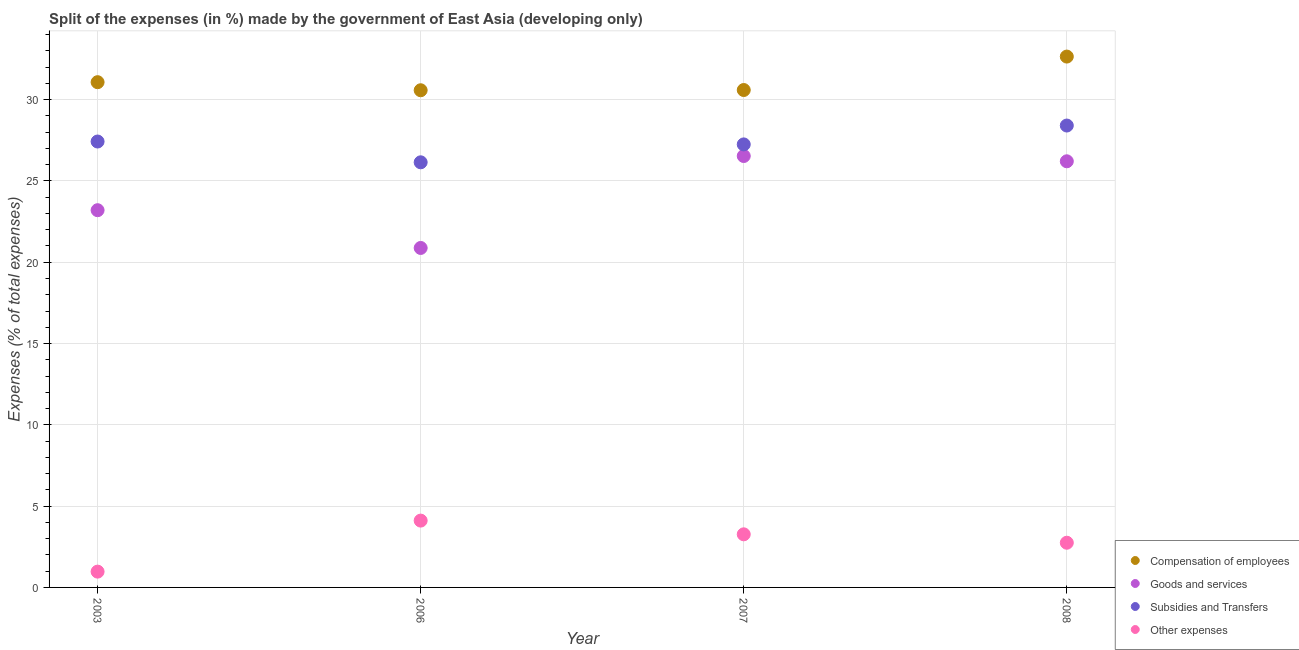What is the percentage of amount spent on other expenses in 2003?
Offer a terse response. 0.97. Across all years, what is the maximum percentage of amount spent on other expenses?
Your response must be concise. 4.11. Across all years, what is the minimum percentage of amount spent on subsidies?
Your answer should be very brief. 26.15. In which year was the percentage of amount spent on compensation of employees minimum?
Provide a short and direct response. 2006. What is the total percentage of amount spent on goods and services in the graph?
Provide a succinct answer. 96.82. What is the difference between the percentage of amount spent on goods and services in 2003 and that in 2008?
Your answer should be compact. -3.01. What is the difference between the percentage of amount spent on subsidies in 2006 and the percentage of amount spent on compensation of employees in 2008?
Your answer should be compact. -6.5. What is the average percentage of amount spent on other expenses per year?
Your answer should be very brief. 2.77. In the year 2003, what is the difference between the percentage of amount spent on goods and services and percentage of amount spent on subsidies?
Provide a succinct answer. -4.22. In how many years, is the percentage of amount spent on subsidies greater than 25 %?
Make the answer very short. 4. What is the ratio of the percentage of amount spent on subsidies in 2006 to that in 2007?
Give a very brief answer. 0.96. What is the difference between the highest and the second highest percentage of amount spent on other expenses?
Your answer should be compact. 0.84. What is the difference between the highest and the lowest percentage of amount spent on subsidies?
Provide a short and direct response. 2.26. In how many years, is the percentage of amount spent on goods and services greater than the average percentage of amount spent on goods and services taken over all years?
Your answer should be compact. 2. Is it the case that in every year, the sum of the percentage of amount spent on compensation of employees and percentage of amount spent on goods and services is greater than the percentage of amount spent on subsidies?
Your answer should be compact. Yes. Does the percentage of amount spent on other expenses monotonically increase over the years?
Give a very brief answer. No. Is the percentage of amount spent on other expenses strictly less than the percentage of amount spent on subsidies over the years?
Offer a very short reply. Yes. How many dotlines are there?
Your answer should be very brief. 4. How many years are there in the graph?
Provide a short and direct response. 4. Are the values on the major ticks of Y-axis written in scientific E-notation?
Keep it short and to the point. No. Does the graph contain any zero values?
Keep it short and to the point. No. Does the graph contain grids?
Make the answer very short. Yes. Where does the legend appear in the graph?
Give a very brief answer. Bottom right. How are the legend labels stacked?
Make the answer very short. Vertical. What is the title of the graph?
Your response must be concise. Split of the expenses (in %) made by the government of East Asia (developing only). What is the label or title of the Y-axis?
Your answer should be very brief. Expenses (% of total expenses). What is the Expenses (% of total expenses) of Compensation of employees in 2003?
Your answer should be very brief. 31.07. What is the Expenses (% of total expenses) in Goods and services in 2003?
Keep it short and to the point. 23.2. What is the Expenses (% of total expenses) in Subsidies and Transfers in 2003?
Your response must be concise. 27.42. What is the Expenses (% of total expenses) in Other expenses in 2003?
Provide a succinct answer. 0.97. What is the Expenses (% of total expenses) of Compensation of employees in 2006?
Make the answer very short. 30.58. What is the Expenses (% of total expenses) in Goods and services in 2006?
Your response must be concise. 20.88. What is the Expenses (% of total expenses) of Subsidies and Transfers in 2006?
Ensure brevity in your answer.  26.15. What is the Expenses (% of total expenses) of Other expenses in 2006?
Make the answer very short. 4.11. What is the Expenses (% of total expenses) in Compensation of employees in 2007?
Your answer should be very brief. 30.59. What is the Expenses (% of total expenses) of Goods and services in 2007?
Your answer should be compact. 26.53. What is the Expenses (% of total expenses) of Subsidies and Transfers in 2007?
Provide a short and direct response. 27.25. What is the Expenses (% of total expenses) in Other expenses in 2007?
Offer a very short reply. 3.27. What is the Expenses (% of total expenses) of Compensation of employees in 2008?
Provide a succinct answer. 32.65. What is the Expenses (% of total expenses) of Goods and services in 2008?
Your answer should be compact. 26.21. What is the Expenses (% of total expenses) of Subsidies and Transfers in 2008?
Provide a succinct answer. 28.41. What is the Expenses (% of total expenses) in Other expenses in 2008?
Offer a very short reply. 2.75. Across all years, what is the maximum Expenses (% of total expenses) of Compensation of employees?
Offer a terse response. 32.65. Across all years, what is the maximum Expenses (% of total expenses) in Goods and services?
Ensure brevity in your answer.  26.53. Across all years, what is the maximum Expenses (% of total expenses) in Subsidies and Transfers?
Your answer should be very brief. 28.41. Across all years, what is the maximum Expenses (% of total expenses) of Other expenses?
Provide a succinct answer. 4.11. Across all years, what is the minimum Expenses (% of total expenses) of Compensation of employees?
Keep it short and to the point. 30.58. Across all years, what is the minimum Expenses (% of total expenses) in Goods and services?
Offer a very short reply. 20.88. Across all years, what is the minimum Expenses (% of total expenses) of Subsidies and Transfers?
Your answer should be compact. 26.15. Across all years, what is the minimum Expenses (% of total expenses) of Other expenses?
Your answer should be compact. 0.97. What is the total Expenses (% of total expenses) in Compensation of employees in the graph?
Make the answer very short. 124.89. What is the total Expenses (% of total expenses) in Goods and services in the graph?
Provide a short and direct response. 96.82. What is the total Expenses (% of total expenses) in Subsidies and Transfers in the graph?
Your answer should be very brief. 109.23. What is the total Expenses (% of total expenses) of Other expenses in the graph?
Your answer should be compact. 11.1. What is the difference between the Expenses (% of total expenses) of Compensation of employees in 2003 and that in 2006?
Your answer should be very brief. 0.5. What is the difference between the Expenses (% of total expenses) of Goods and services in 2003 and that in 2006?
Your response must be concise. 2.32. What is the difference between the Expenses (% of total expenses) in Subsidies and Transfers in 2003 and that in 2006?
Keep it short and to the point. 1.28. What is the difference between the Expenses (% of total expenses) in Other expenses in 2003 and that in 2006?
Provide a succinct answer. -3.14. What is the difference between the Expenses (% of total expenses) in Compensation of employees in 2003 and that in 2007?
Your answer should be very brief. 0.48. What is the difference between the Expenses (% of total expenses) of Goods and services in 2003 and that in 2007?
Provide a succinct answer. -3.33. What is the difference between the Expenses (% of total expenses) in Subsidies and Transfers in 2003 and that in 2007?
Your response must be concise. 0.18. What is the difference between the Expenses (% of total expenses) in Other expenses in 2003 and that in 2007?
Make the answer very short. -2.29. What is the difference between the Expenses (% of total expenses) in Compensation of employees in 2003 and that in 2008?
Provide a short and direct response. -1.57. What is the difference between the Expenses (% of total expenses) of Goods and services in 2003 and that in 2008?
Provide a succinct answer. -3.01. What is the difference between the Expenses (% of total expenses) in Subsidies and Transfers in 2003 and that in 2008?
Offer a terse response. -0.98. What is the difference between the Expenses (% of total expenses) in Other expenses in 2003 and that in 2008?
Keep it short and to the point. -1.78. What is the difference between the Expenses (% of total expenses) of Compensation of employees in 2006 and that in 2007?
Keep it short and to the point. -0.01. What is the difference between the Expenses (% of total expenses) in Goods and services in 2006 and that in 2007?
Offer a very short reply. -5.65. What is the difference between the Expenses (% of total expenses) of Subsidies and Transfers in 2006 and that in 2007?
Your answer should be very brief. -1.1. What is the difference between the Expenses (% of total expenses) in Other expenses in 2006 and that in 2007?
Give a very brief answer. 0.84. What is the difference between the Expenses (% of total expenses) of Compensation of employees in 2006 and that in 2008?
Your answer should be compact. -2.07. What is the difference between the Expenses (% of total expenses) in Goods and services in 2006 and that in 2008?
Ensure brevity in your answer.  -5.33. What is the difference between the Expenses (% of total expenses) in Subsidies and Transfers in 2006 and that in 2008?
Your answer should be compact. -2.26. What is the difference between the Expenses (% of total expenses) of Other expenses in 2006 and that in 2008?
Provide a succinct answer. 1.36. What is the difference between the Expenses (% of total expenses) of Compensation of employees in 2007 and that in 2008?
Provide a short and direct response. -2.06. What is the difference between the Expenses (% of total expenses) in Goods and services in 2007 and that in 2008?
Provide a short and direct response. 0.32. What is the difference between the Expenses (% of total expenses) in Subsidies and Transfers in 2007 and that in 2008?
Ensure brevity in your answer.  -1.16. What is the difference between the Expenses (% of total expenses) of Other expenses in 2007 and that in 2008?
Make the answer very short. 0.52. What is the difference between the Expenses (% of total expenses) of Compensation of employees in 2003 and the Expenses (% of total expenses) of Goods and services in 2006?
Offer a very short reply. 10.2. What is the difference between the Expenses (% of total expenses) in Compensation of employees in 2003 and the Expenses (% of total expenses) in Subsidies and Transfers in 2006?
Give a very brief answer. 4.93. What is the difference between the Expenses (% of total expenses) of Compensation of employees in 2003 and the Expenses (% of total expenses) of Other expenses in 2006?
Offer a very short reply. 26.96. What is the difference between the Expenses (% of total expenses) of Goods and services in 2003 and the Expenses (% of total expenses) of Subsidies and Transfers in 2006?
Make the answer very short. -2.95. What is the difference between the Expenses (% of total expenses) of Goods and services in 2003 and the Expenses (% of total expenses) of Other expenses in 2006?
Your response must be concise. 19.09. What is the difference between the Expenses (% of total expenses) of Subsidies and Transfers in 2003 and the Expenses (% of total expenses) of Other expenses in 2006?
Make the answer very short. 23.32. What is the difference between the Expenses (% of total expenses) in Compensation of employees in 2003 and the Expenses (% of total expenses) in Goods and services in 2007?
Offer a very short reply. 4.54. What is the difference between the Expenses (% of total expenses) of Compensation of employees in 2003 and the Expenses (% of total expenses) of Subsidies and Transfers in 2007?
Keep it short and to the point. 3.83. What is the difference between the Expenses (% of total expenses) in Compensation of employees in 2003 and the Expenses (% of total expenses) in Other expenses in 2007?
Your answer should be compact. 27.81. What is the difference between the Expenses (% of total expenses) in Goods and services in 2003 and the Expenses (% of total expenses) in Subsidies and Transfers in 2007?
Keep it short and to the point. -4.05. What is the difference between the Expenses (% of total expenses) of Goods and services in 2003 and the Expenses (% of total expenses) of Other expenses in 2007?
Give a very brief answer. 19.93. What is the difference between the Expenses (% of total expenses) of Subsidies and Transfers in 2003 and the Expenses (% of total expenses) of Other expenses in 2007?
Keep it short and to the point. 24.16. What is the difference between the Expenses (% of total expenses) in Compensation of employees in 2003 and the Expenses (% of total expenses) in Goods and services in 2008?
Your response must be concise. 4.87. What is the difference between the Expenses (% of total expenses) in Compensation of employees in 2003 and the Expenses (% of total expenses) in Subsidies and Transfers in 2008?
Your answer should be very brief. 2.67. What is the difference between the Expenses (% of total expenses) of Compensation of employees in 2003 and the Expenses (% of total expenses) of Other expenses in 2008?
Provide a short and direct response. 28.33. What is the difference between the Expenses (% of total expenses) of Goods and services in 2003 and the Expenses (% of total expenses) of Subsidies and Transfers in 2008?
Offer a very short reply. -5.21. What is the difference between the Expenses (% of total expenses) in Goods and services in 2003 and the Expenses (% of total expenses) in Other expenses in 2008?
Offer a terse response. 20.45. What is the difference between the Expenses (% of total expenses) in Subsidies and Transfers in 2003 and the Expenses (% of total expenses) in Other expenses in 2008?
Ensure brevity in your answer.  24.68. What is the difference between the Expenses (% of total expenses) of Compensation of employees in 2006 and the Expenses (% of total expenses) of Goods and services in 2007?
Make the answer very short. 4.04. What is the difference between the Expenses (% of total expenses) in Compensation of employees in 2006 and the Expenses (% of total expenses) in Subsidies and Transfers in 2007?
Provide a short and direct response. 3.33. What is the difference between the Expenses (% of total expenses) of Compensation of employees in 2006 and the Expenses (% of total expenses) of Other expenses in 2007?
Provide a short and direct response. 27.31. What is the difference between the Expenses (% of total expenses) of Goods and services in 2006 and the Expenses (% of total expenses) of Subsidies and Transfers in 2007?
Make the answer very short. -6.37. What is the difference between the Expenses (% of total expenses) in Goods and services in 2006 and the Expenses (% of total expenses) in Other expenses in 2007?
Keep it short and to the point. 17.61. What is the difference between the Expenses (% of total expenses) of Subsidies and Transfers in 2006 and the Expenses (% of total expenses) of Other expenses in 2007?
Give a very brief answer. 22.88. What is the difference between the Expenses (% of total expenses) in Compensation of employees in 2006 and the Expenses (% of total expenses) in Goods and services in 2008?
Give a very brief answer. 4.37. What is the difference between the Expenses (% of total expenses) of Compensation of employees in 2006 and the Expenses (% of total expenses) of Subsidies and Transfers in 2008?
Ensure brevity in your answer.  2.17. What is the difference between the Expenses (% of total expenses) in Compensation of employees in 2006 and the Expenses (% of total expenses) in Other expenses in 2008?
Your response must be concise. 27.83. What is the difference between the Expenses (% of total expenses) in Goods and services in 2006 and the Expenses (% of total expenses) in Subsidies and Transfers in 2008?
Give a very brief answer. -7.53. What is the difference between the Expenses (% of total expenses) in Goods and services in 2006 and the Expenses (% of total expenses) in Other expenses in 2008?
Give a very brief answer. 18.13. What is the difference between the Expenses (% of total expenses) in Subsidies and Transfers in 2006 and the Expenses (% of total expenses) in Other expenses in 2008?
Offer a terse response. 23.4. What is the difference between the Expenses (% of total expenses) in Compensation of employees in 2007 and the Expenses (% of total expenses) in Goods and services in 2008?
Your answer should be compact. 4.38. What is the difference between the Expenses (% of total expenses) of Compensation of employees in 2007 and the Expenses (% of total expenses) of Subsidies and Transfers in 2008?
Keep it short and to the point. 2.18. What is the difference between the Expenses (% of total expenses) of Compensation of employees in 2007 and the Expenses (% of total expenses) of Other expenses in 2008?
Your answer should be compact. 27.84. What is the difference between the Expenses (% of total expenses) of Goods and services in 2007 and the Expenses (% of total expenses) of Subsidies and Transfers in 2008?
Your response must be concise. -1.87. What is the difference between the Expenses (% of total expenses) of Goods and services in 2007 and the Expenses (% of total expenses) of Other expenses in 2008?
Provide a succinct answer. 23.78. What is the difference between the Expenses (% of total expenses) of Subsidies and Transfers in 2007 and the Expenses (% of total expenses) of Other expenses in 2008?
Give a very brief answer. 24.5. What is the average Expenses (% of total expenses) of Compensation of employees per year?
Ensure brevity in your answer.  31.22. What is the average Expenses (% of total expenses) of Goods and services per year?
Ensure brevity in your answer.  24.21. What is the average Expenses (% of total expenses) in Subsidies and Transfers per year?
Ensure brevity in your answer.  27.31. What is the average Expenses (% of total expenses) in Other expenses per year?
Your answer should be compact. 2.77. In the year 2003, what is the difference between the Expenses (% of total expenses) in Compensation of employees and Expenses (% of total expenses) in Goods and services?
Make the answer very short. 7.87. In the year 2003, what is the difference between the Expenses (% of total expenses) of Compensation of employees and Expenses (% of total expenses) of Subsidies and Transfers?
Ensure brevity in your answer.  3.65. In the year 2003, what is the difference between the Expenses (% of total expenses) in Compensation of employees and Expenses (% of total expenses) in Other expenses?
Make the answer very short. 30.1. In the year 2003, what is the difference between the Expenses (% of total expenses) in Goods and services and Expenses (% of total expenses) in Subsidies and Transfers?
Offer a very short reply. -4.22. In the year 2003, what is the difference between the Expenses (% of total expenses) of Goods and services and Expenses (% of total expenses) of Other expenses?
Your answer should be compact. 22.23. In the year 2003, what is the difference between the Expenses (% of total expenses) in Subsidies and Transfers and Expenses (% of total expenses) in Other expenses?
Ensure brevity in your answer.  26.45. In the year 2006, what is the difference between the Expenses (% of total expenses) in Compensation of employees and Expenses (% of total expenses) in Goods and services?
Provide a short and direct response. 9.7. In the year 2006, what is the difference between the Expenses (% of total expenses) of Compensation of employees and Expenses (% of total expenses) of Subsidies and Transfers?
Make the answer very short. 4.43. In the year 2006, what is the difference between the Expenses (% of total expenses) of Compensation of employees and Expenses (% of total expenses) of Other expenses?
Your response must be concise. 26.47. In the year 2006, what is the difference between the Expenses (% of total expenses) in Goods and services and Expenses (% of total expenses) in Subsidies and Transfers?
Make the answer very short. -5.27. In the year 2006, what is the difference between the Expenses (% of total expenses) in Goods and services and Expenses (% of total expenses) in Other expenses?
Your answer should be very brief. 16.77. In the year 2006, what is the difference between the Expenses (% of total expenses) in Subsidies and Transfers and Expenses (% of total expenses) in Other expenses?
Provide a succinct answer. 22.04. In the year 2007, what is the difference between the Expenses (% of total expenses) in Compensation of employees and Expenses (% of total expenses) in Goods and services?
Give a very brief answer. 4.06. In the year 2007, what is the difference between the Expenses (% of total expenses) in Compensation of employees and Expenses (% of total expenses) in Subsidies and Transfers?
Give a very brief answer. 3.34. In the year 2007, what is the difference between the Expenses (% of total expenses) in Compensation of employees and Expenses (% of total expenses) in Other expenses?
Your response must be concise. 27.33. In the year 2007, what is the difference between the Expenses (% of total expenses) in Goods and services and Expenses (% of total expenses) in Subsidies and Transfers?
Keep it short and to the point. -0.71. In the year 2007, what is the difference between the Expenses (% of total expenses) of Goods and services and Expenses (% of total expenses) of Other expenses?
Make the answer very short. 23.27. In the year 2007, what is the difference between the Expenses (% of total expenses) in Subsidies and Transfers and Expenses (% of total expenses) in Other expenses?
Offer a terse response. 23.98. In the year 2008, what is the difference between the Expenses (% of total expenses) of Compensation of employees and Expenses (% of total expenses) of Goods and services?
Make the answer very short. 6.44. In the year 2008, what is the difference between the Expenses (% of total expenses) of Compensation of employees and Expenses (% of total expenses) of Subsidies and Transfers?
Ensure brevity in your answer.  4.24. In the year 2008, what is the difference between the Expenses (% of total expenses) of Compensation of employees and Expenses (% of total expenses) of Other expenses?
Your answer should be compact. 29.9. In the year 2008, what is the difference between the Expenses (% of total expenses) in Goods and services and Expenses (% of total expenses) in Subsidies and Transfers?
Offer a terse response. -2.2. In the year 2008, what is the difference between the Expenses (% of total expenses) in Goods and services and Expenses (% of total expenses) in Other expenses?
Your answer should be very brief. 23.46. In the year 2008, what is the difference between the Expenses (% of total expenses) in Subsidies and Transfers and Expenses (% of total expenses) in Other expenses?
Offer a terse response. 25.66. What is the ratio of the Expenses (% of total expenses) of Compensation of employees in 2003 to that in 2006?
Ensure brevity in your answer.  1.02. What is the ratio of the Expenses (% of total expenses) in Goods and services in 2003 to that in 2006?
Your response must be concise. 1.11. What is the ratio of the Expenses (% of total expenses) in Subsidies and Transfers in 2003 to that in 2006?
Your answer should be very brief. 1.05. What is the ratio of the Expenses (% of total expenses) of Other expenses in 2003 to that in 2006?
Provide a succinct answer. 0.24. What is the ratio of the Expenses (% of total expenses) in Compensation of employees in 2003 to that in 2007?
Offer a very short reply. 1.02. What is the ratio of the Expenses (% of total expenses) in Goods and services in 2003 to that in 2007?
Give a very brief answer. 0.87. What is the ratio of the Expenses (% of total expenses) in Other expenses in 2003 to that in 2007?
Provide a short and direct response. 0.3. What is the ratio of the Expenses (% of total expenses) of Compensation of employees in 2003 to that in 2008?
Provide a succinct answer. 0.95. What is the ratio of the Expenses (% of total expenses) of Goods and services in 2003 to that in 2008?
Offer a very short reply. 0.89. What is the ratio of the Expenses (% of total expenses) in Subsidies and Transfers in 2003 to that in 2008?
Provide a succinct answer. 0.97. What is the ratio of the Expenses (% of total expenses) of Other expenses in 2003 to that in 2008?
Your response must be concise. 0.35. What is the ratio of the Expenses (% of total expenses) in Goods and services in 2006 to that in 2007?
Give a very brief answer. 0.79. What is the ratio of the Expenses (% of total expenses) in Subsidies and Transfers in 2006 to that in 2007?
Offer a terse response. 0.96. What is the ratio of the Expenses (% of total expenses) in Other expenses in 2006 to that in 2007?
Your response must be concise. 1.26. What is the ratio of the Expenses (% of total expenses) of Compensation of employees in 2006 to that in 2008?
Provide a short and direct response. 0.94. What is the ratio of the Expenses (% of total expenses) of Goods and services in 2006 to that in 2008?
Provide a short and direct response. 0.8. What is the ratio of the Expenses (% of total expenses) in Subsidies and Transfers in 2006 to that in 2008?
Offer a terse response. 0.92. What is the ratio of the Expenses (% of total expenses) of Other expenses in 2006 to that in 2008?
Your answer should be compact. 1.5. What is the ratio of the Expenses (% of total expenses) in Compensation of employees in 2007 to that in 2008?
Provide a short and direct response. 0.94. What is the ratio of the Expenses (% of total expenses) of Goods and services in 2007 to that in 2008?
Offer a terse response. 1.01. What is the ratio of the Expenses (% of total expenses) in Subsidies and Transfers in 2007 to that in 2008?
Provide a short and direct response. 0.96. What is the ratio of the Expenses (% of total expenses) of Other expenses in 2007 to that in 2008?
Give a very brief answer. 1.19. What is the difference between the highest and the second highest Expenses (% of total expenses) of Compensation of employees?
Keep it short and to the point. 1.57. What is the difference between the highest and the second highest Expenses (% of total expenses) of Goods and services?
Keep it short and to the point. 0.32. What is the difference between the highest and the second highest Expenses (% of total expenses) of Subsidies and Transfers?
Make the answer very short. 0.98. What is the difference between the highest and the second highest Expenses (% of total expenses) in Other expenses?
Keep it short and to the point. 0.84. What is the difference between the highest and the lowest Expenses (% of total expenses) of Compensation of employees?
Make the answer very short. 2.07. What is the difference between the highest and the lowest Expenses (% of total expenses) in Goods and services?
Offer a terse response. 5.65. What is the difference between the highest and the lowest Expenses (% of total expenses) of Subsidies and Transfers?
Provide a succinct answer. 2.26. What is the difference between the highest and the lowest Expenses (% of total expenses) of Other expenses?
Keep it short and to the point. 3.14. 